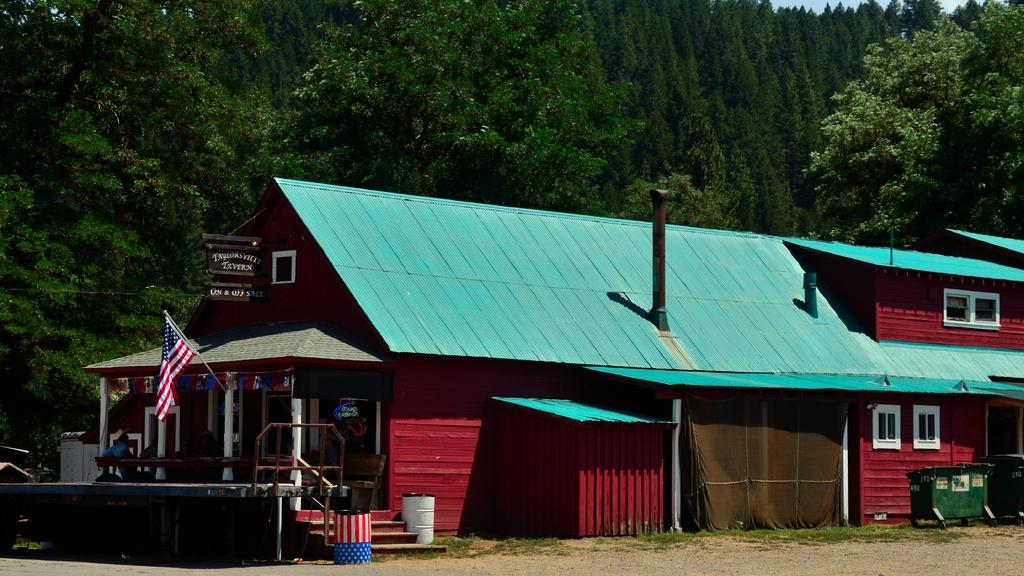What type of structures can be seen in the image? There are houses in the image. What feature is common to many of the houses in the image? There are windows in the image. What is the symbolic object visible in the image? There is a flag in the image. What are the two cylindrical objects in the image? There are two barrels in the image. What type of signage is present in the image? There are boards with text in the image. Who or what is present in the image? There are people in the image. What type of natural vegetation is visible in the image? There are trees in the image. What part of the natural environment is visible in the image? The sky is visible in the image. Can you see the ocean in the image? No, the ocean is not present in the image. What type of toys can be seen in the hands of the people in the image? There are no toys visible in the image; only people, houses, windows, a flag, barrels, boards with text, trees, and the sky are present. 